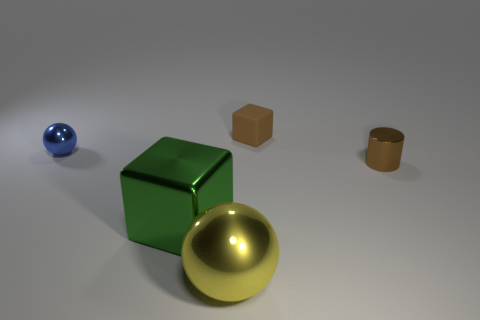Add 4 cyan rubber spheres. How many objects exist? 9 Subtract all cylinders. How many objects are left? 4 Subtract all cyan cylinders. Subtract all large green shiny blocks. How many objects are left? 4 Add 1 tiny shiny balls. How many tiny shiny balls are left? 2 Add 2 tiny metallic objects. How many tiny metallic objects exist? 4 Subtract 0 green cylinders. How many objects are left? 5 